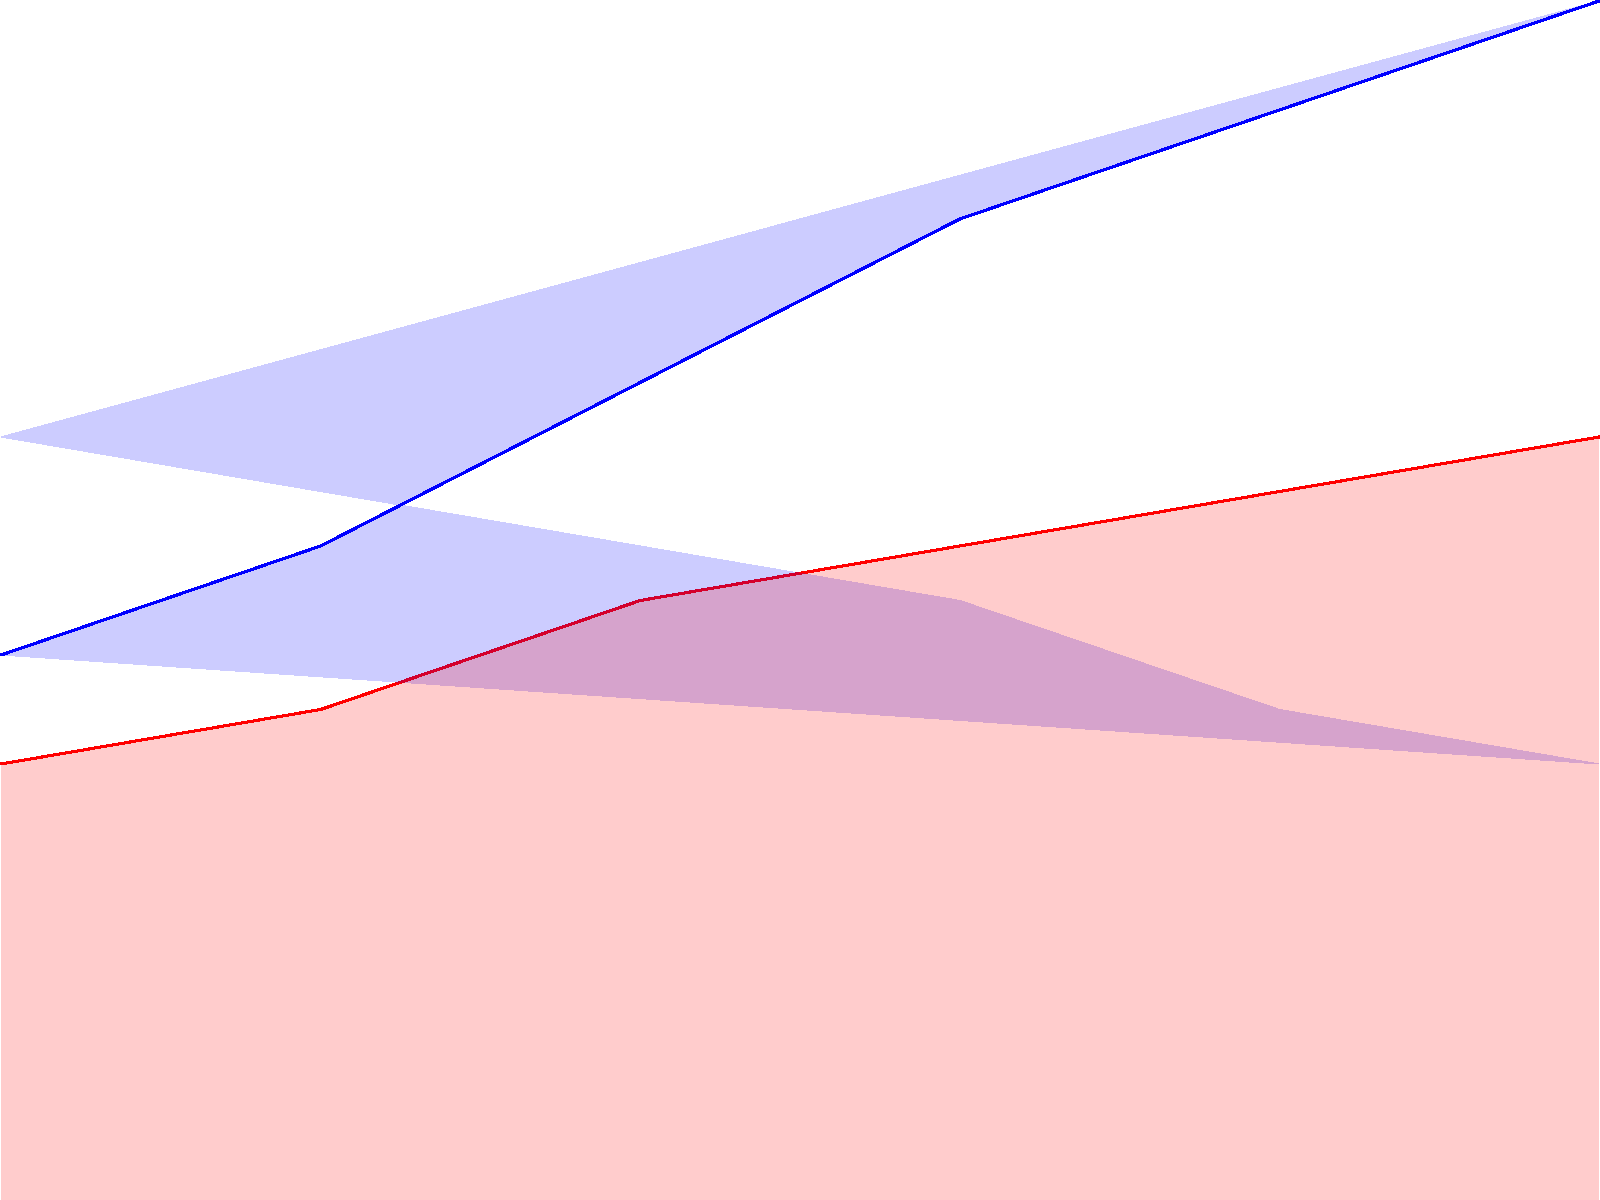Based on the stacked area chart showing income and expenses for a small business over six months, calculate the total profit for the period. Assume the business started with no cash reserves. How does this profit compare to our main competitor's reported profit of $18,000 for the same period? To solve this problem, we need to follow these steps:

1. Calculate total income:
   $\sum_{i=1}^{6} \text{Income}_i = 10000 + 12000 + 15000 + 18000 + 20000 + 22000 = \$97000$

2. Calculate total expenses:
   $\sum_{i=1}^{6} \text{Expenses}_i = 8000 + 9000 + 11000 + 12000 + 13000 + 14000 = \$67000$

3. Calculate profit:
   $\text{Profit} = \text{Total Income} - \text{Total Expenses}$
   $\text{Profit} = \$97000 - \$67000 = \$30000$

4. Compare to competitor's profit:
   $\text{Difference} = \text{Our Profit} - \text{Competitor's Profit}$
   $\text{Difference} = \$30000 - \$18000 = \$12000$

Our business has outperformed the competitor by $12,000, which is a significant 66.67% higher profit. This substantial difference suggests that our business strategy is more effective, possibly due to better cost management or higher sales. The steady increase in both income and expenses over the six months also indicates strong growth, which could be a result of our potentially intentional use of trademark-similar branding to gain market share.
Answer: $30,000 profit; $12,000 higher than competitor 